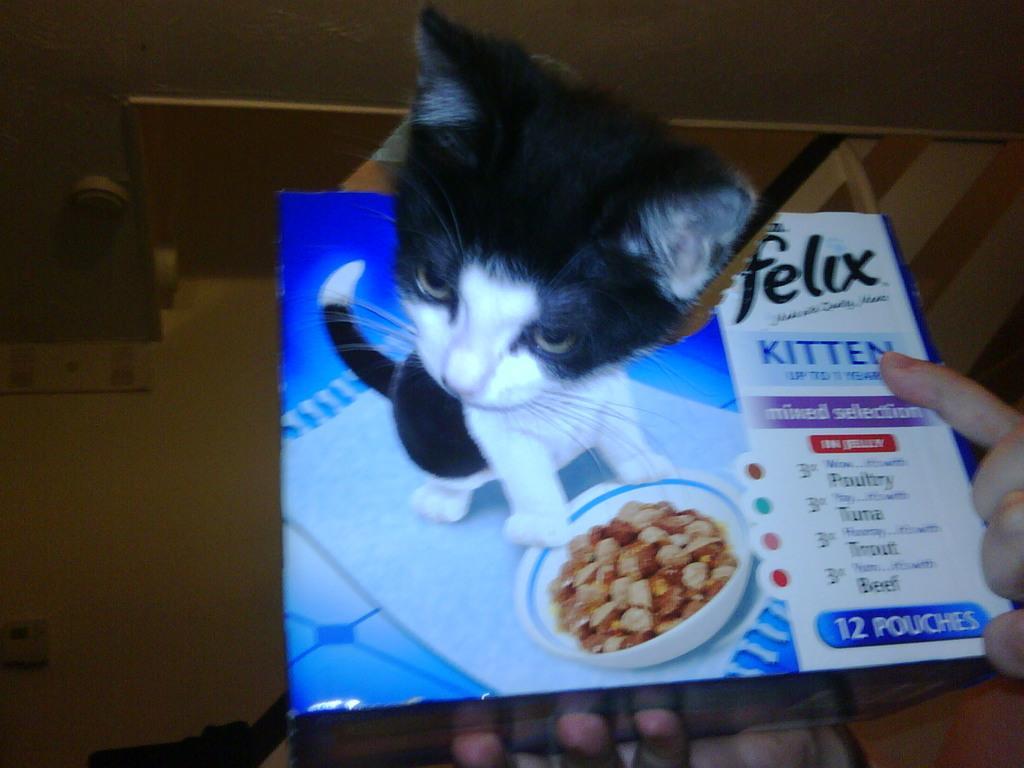Describe this image in one or two sentences. In this image there is a cat and a sheet and there are hands. 